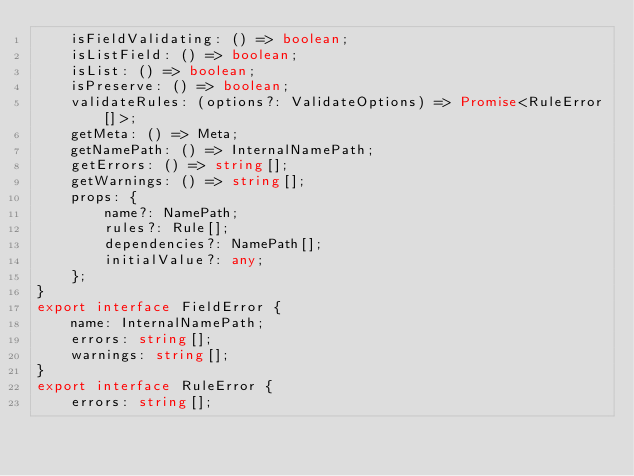<code> <loc_0><loc_0><loc_500><loc_500><_TypeScript_>    isFieldValidating: () => boolean;
    isListField: () => boolean;
    isList: () => boolean;
    isPreserve: () => boolean;
    validateRules: (options?: ValidateOptions) => Promise<RuleError[]>;
    getMeta: () => Meta;
    getNamePath: () => InternalNamePath;
    getErrors: () => string[];
    getWarnings: () => string[];
    props: {
        name?: NamePath;
        rules?: Rule[];
        dependencies?: NamePath[];
        initialValue?: any;
    };
}
export interface FieldError {
    name: InternalNamePath;
    errors: string[];
    warnings: string[];
}
export interface RuleError {
    errors: string[];</code> 